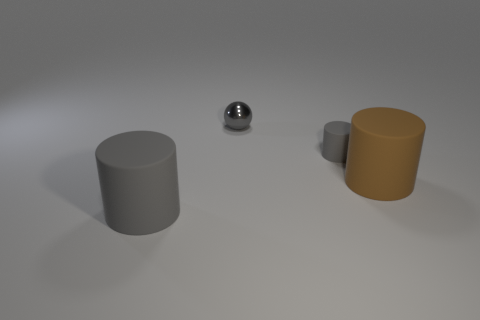Add 4 small purple metallic spheres. How many objects exist? 8 Subtract all cylinders. How many objects are left? 1 Subtract all small gray cylinders. Subtract all small gray cylinders. How many objects are left? 2 Add 2 small spheres. How many small spheres are left? 3 Add 3 big brown balls. How many big brown balls exist? 3 Subtract 0 brown spheres. How many objects are left? 4 